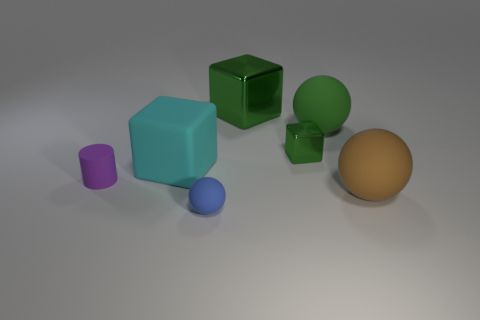How many small purple things have the same material as the green ball?
Your answer should be very brief. 1. Are there more spheres than objects?
Your answer should be very brief. No. There is a large rubber object behind the large cyan block; what number of green shiny cubes are in front of it?
Provide a short and direct response. 1. How many objects are objects that are right of the big green matte ball or large objects?
Offer a terse response. 4. Is there a big cyan matte object of the same shape as the large metal object?
Offer a terse response. Yes. What shape is the object in front of the big matte thing in front of the matte cylinder?
Offer a very short reply. Sphere. How many balls are cyan things or purple things?
Offer a very short reply. 0. There is a large block that is the same color as the small metallic cube; what is it made of?
Provide a succinct answer. Metal. Is the shape of the tiny matte thing in front of the big brown thing the same as the large rubber thing behind the cyan object?
Keep it short and to the point. Yes. There is a tiny thing that is in front of the tiny cube and right of the small rubber cylinder; what color is it?
Your answer should be very brief. Blue. 